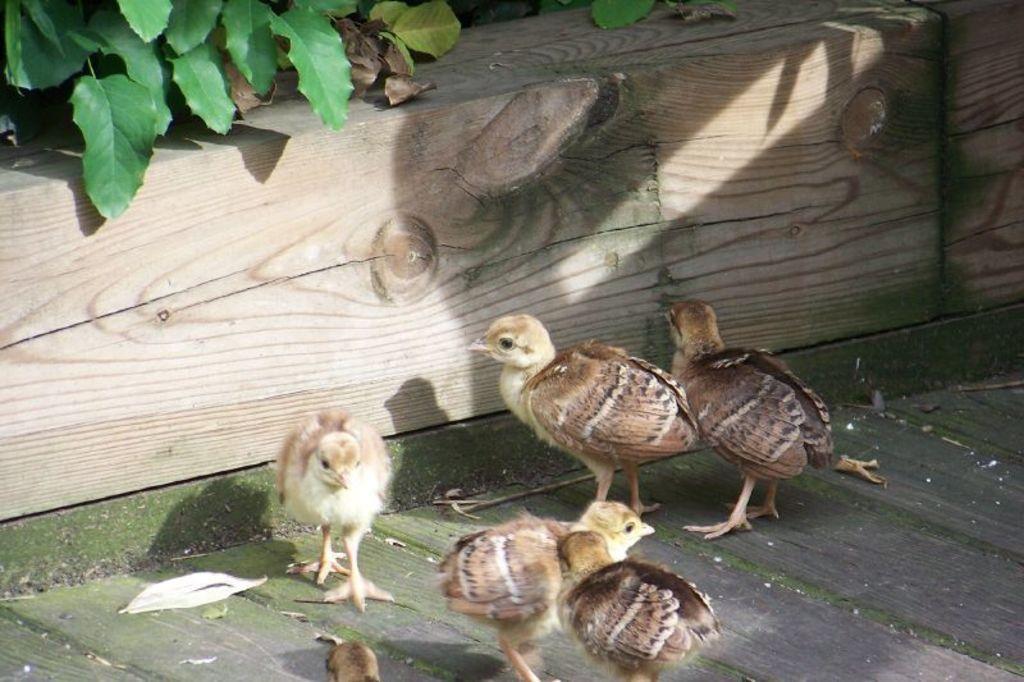Please provide a concise description of this image. In this image there are chicks on a wooden floor, in the background there is plant. 